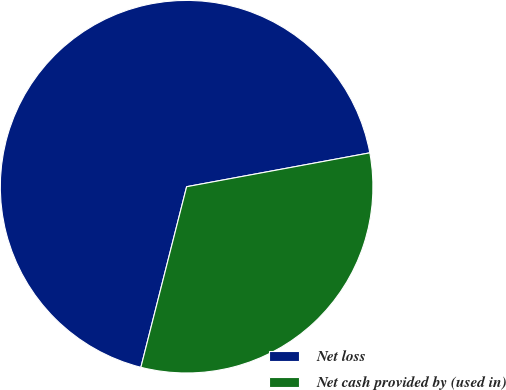Convert chart to OTSL. <chart><loc_0><loc_0><loc_500><loc_500><pie_chart><fcel>Net loss<fcel>Net cash provided by (used in)<nl><fcel>68.14%<fcel>31.86%<nl></chart> 